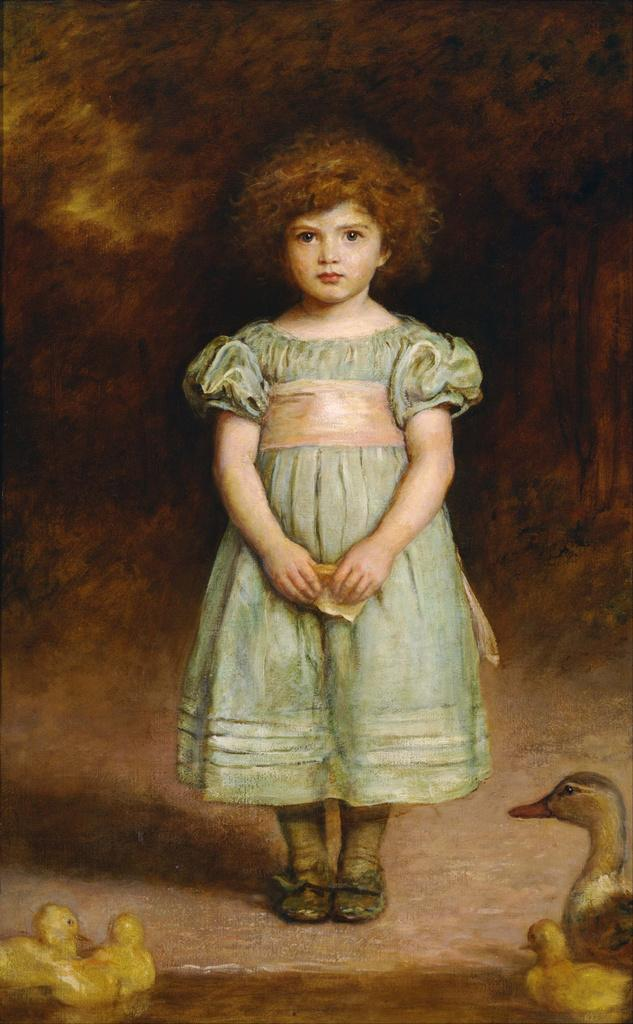What is the main subject of the image? There is a girl standing in the image. What is the girl wearing? The girl is wearing a frock. What other animals are present in the image? There is a duck and ducklings in the image. Can you describe the background of the image? The backdrop is blurred. What type of artwork is this? This is a painting. What is the current date on the calendar in the image? There is no calendar present in the image, so the current date cannot be determined. 